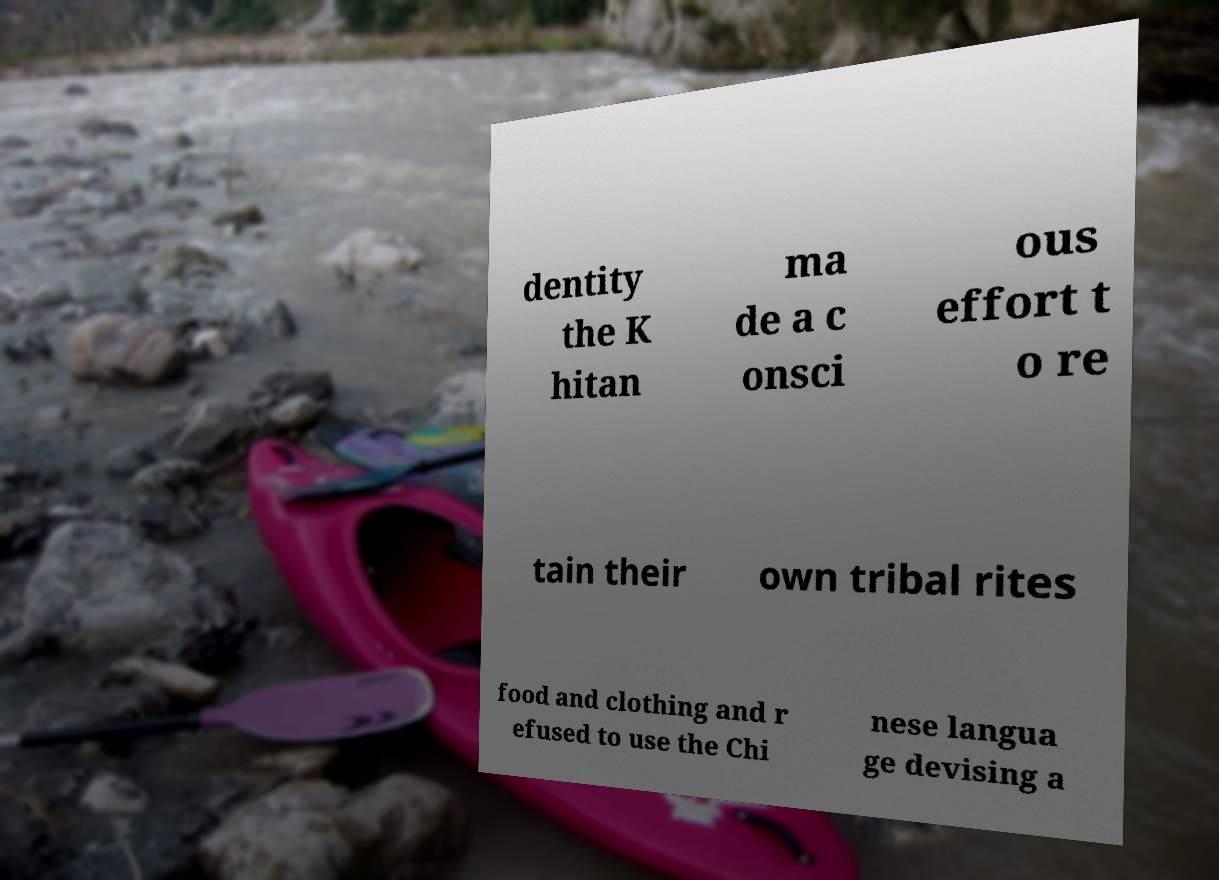There's text embedded in this image that I need extracted. Can you transcribe it verbatim? dentity the K hitan ma de a c onsci ous effort t o re tain their own tribal rites food and clothing and r efused to use the Chi nese langua ge devising a 